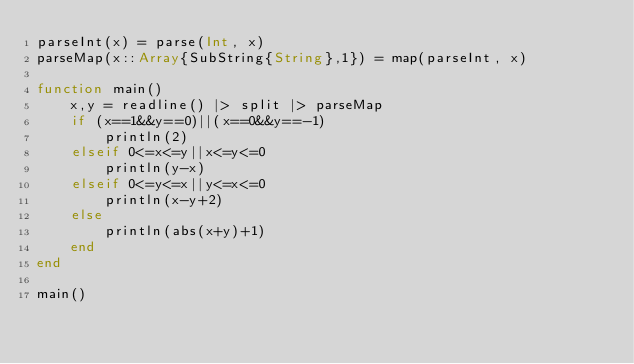<code> <loc_0><loc_0><loc_500><loc_500><_Julia_>parseInt(x) = parse(Int, x)
parseMap(x::Array{SubString{String},1}) = map(parseInt, x)

function main()
	x,y = readline() |> split |> parseMap
	if (x==1&&y==0)||(x==0&&y==-1)
		println(2)
	elseif 0<=x<=y||x<=y<=0
		println(y-x)
	elseif 0<=y<=x||y<=x<=0
		println(x-y+2)
	else
		println(abs(x+y)+1)
	end
end

main()</code> 